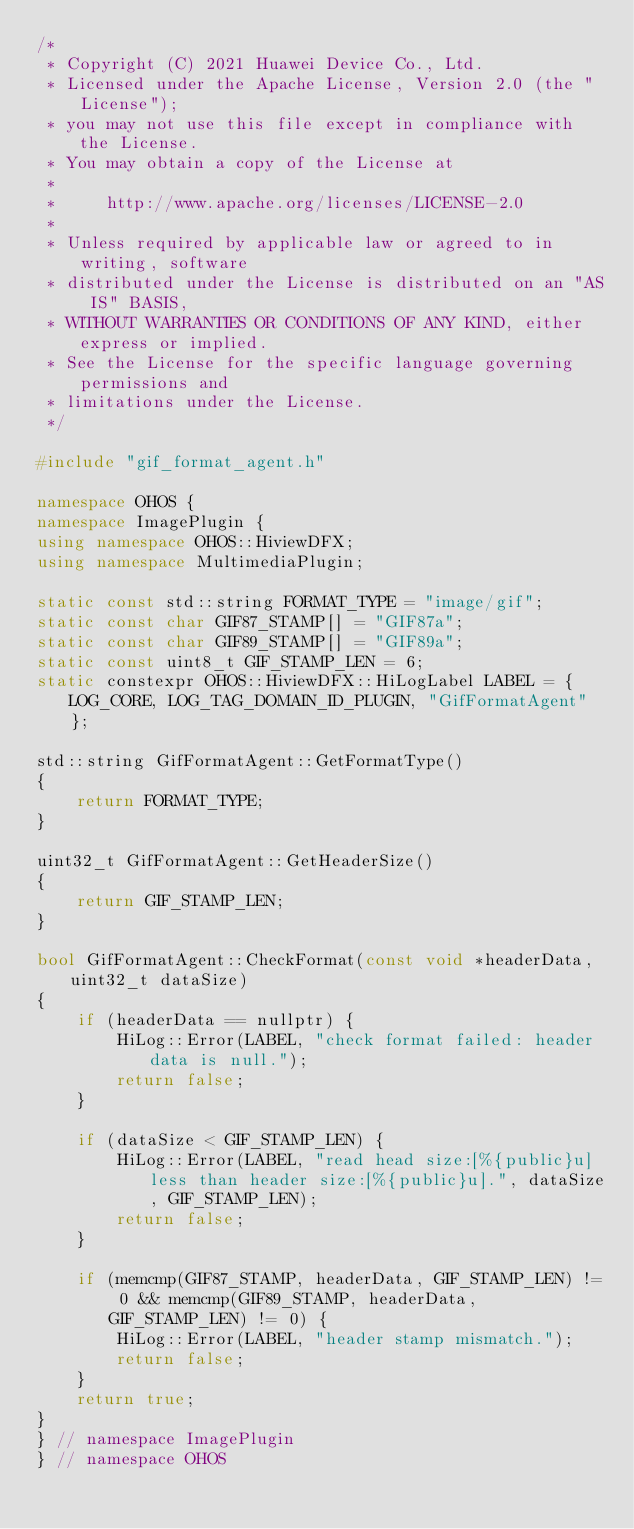Convert code to text. <code><loc_0><loc_0><loc_500><loc_500><_C++_>/*
 * Copyright (C) 2021 Huawei Device Co., Ltd.
 * Licensed under the Apache License, Version 2.0 (the "License");
 * you may not use this file except in compliance with the License.
 * You may obtain a copy of the License at
 *
 *     http://www.apache.org/licenses/LICENSE-2.0
 *
 * Unless required by applicable law or agreed to in writing, software
 * distributed under the License is distributed on an "AS IS" BASIS,
 * WITHOUT WARRANTIES OR CONDITIONS OF ANY KIND, either express or implied.
 * See the License for the specific language governing permissions and
 * limitations under the License.
 */

#include "gif_format_agent.h"

namespace OHOS {
namespace ImagePlugin {
using namespace OHOS::HiviewDFX;
using namespace MultimediaPlugin;

static const std::string FORMAT_TYPE = "image/gif";
static const char GIF87_STAMP[] = "GIF87a";
static const char GIF89_STAMP[] = "GIF89a";
static const uint8_t GIF_STAMP_LEN = 6;
static constexpr OHOS::HiviewDFX::HiLogLabel LABEL = { LOG_CORE, LOG_TAG_DOMAIN_ID_PLUGIN, "GifFormatAgent" };

std::string GifFormatAgent::GetFormatType()
{
    return FORMAT_TYPE;
}

uint32_t GifFormatAgent::GetHeaderSize()
{
    return GIF_STAMP_LEN;
}

bool GifFormatAgent::CheckFormat(const void *headerData, uint32_t dataSize)
{
    if (headerData == nullptr) {
        HiLog::Error(LABEL, "check format failed: header data is null.");
        return false;
    }

    if (dataSize < GIF_STAMP_LEN) {
        HiLog::Error(LABEL, "read head size:[%{public}u] less than header size:[%{public}u].", dataSize, GIF_STAMP_LEN);
        return false;
    }

    if (memcmp(GIF87_STAMP, headerData, GIF_STAMP_LEN) != 0 && memcmp(GIF89_STAMP, headerData, GIF_STAMP_LEN) != 0) {
        HiLog::Error(LABEL, "header stamp mismatch.");
        return false;
    }
    return true;
}
} // namespace ImagePlugin
} // namespace OHOS
</code> 